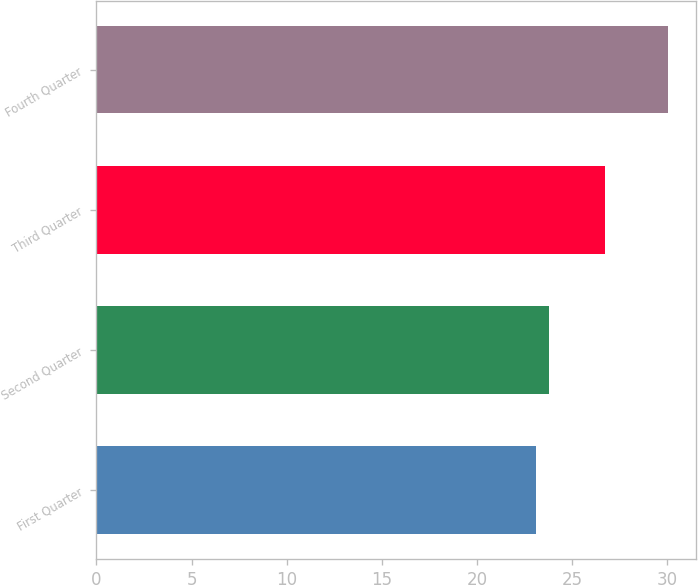Convert chart. <chart><loc_0><loc_0><loc_500><loc_500><bar_chart><fcel>First Quarter<fcel>Second Quarter<fcel>Third Quarter<fcel>Fourth Quarter<nl><fcel>23.1<fcel>23.79<fcel>26.74<fcel>30.02<nl></chart> 